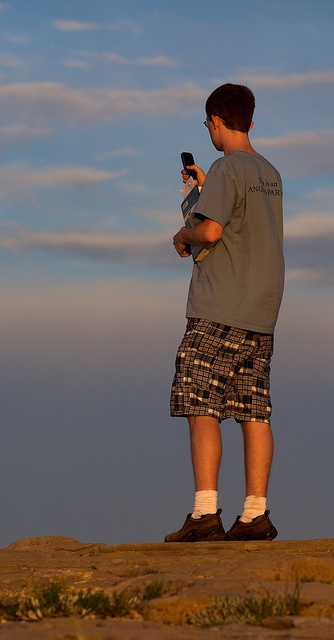Describe the objects in this image and their specific colors. I can see people in gray, maroon, and black tones, book in gray, black, maroon, and brown tones, and cell phone in gray, black, and maroon tones in this image. 